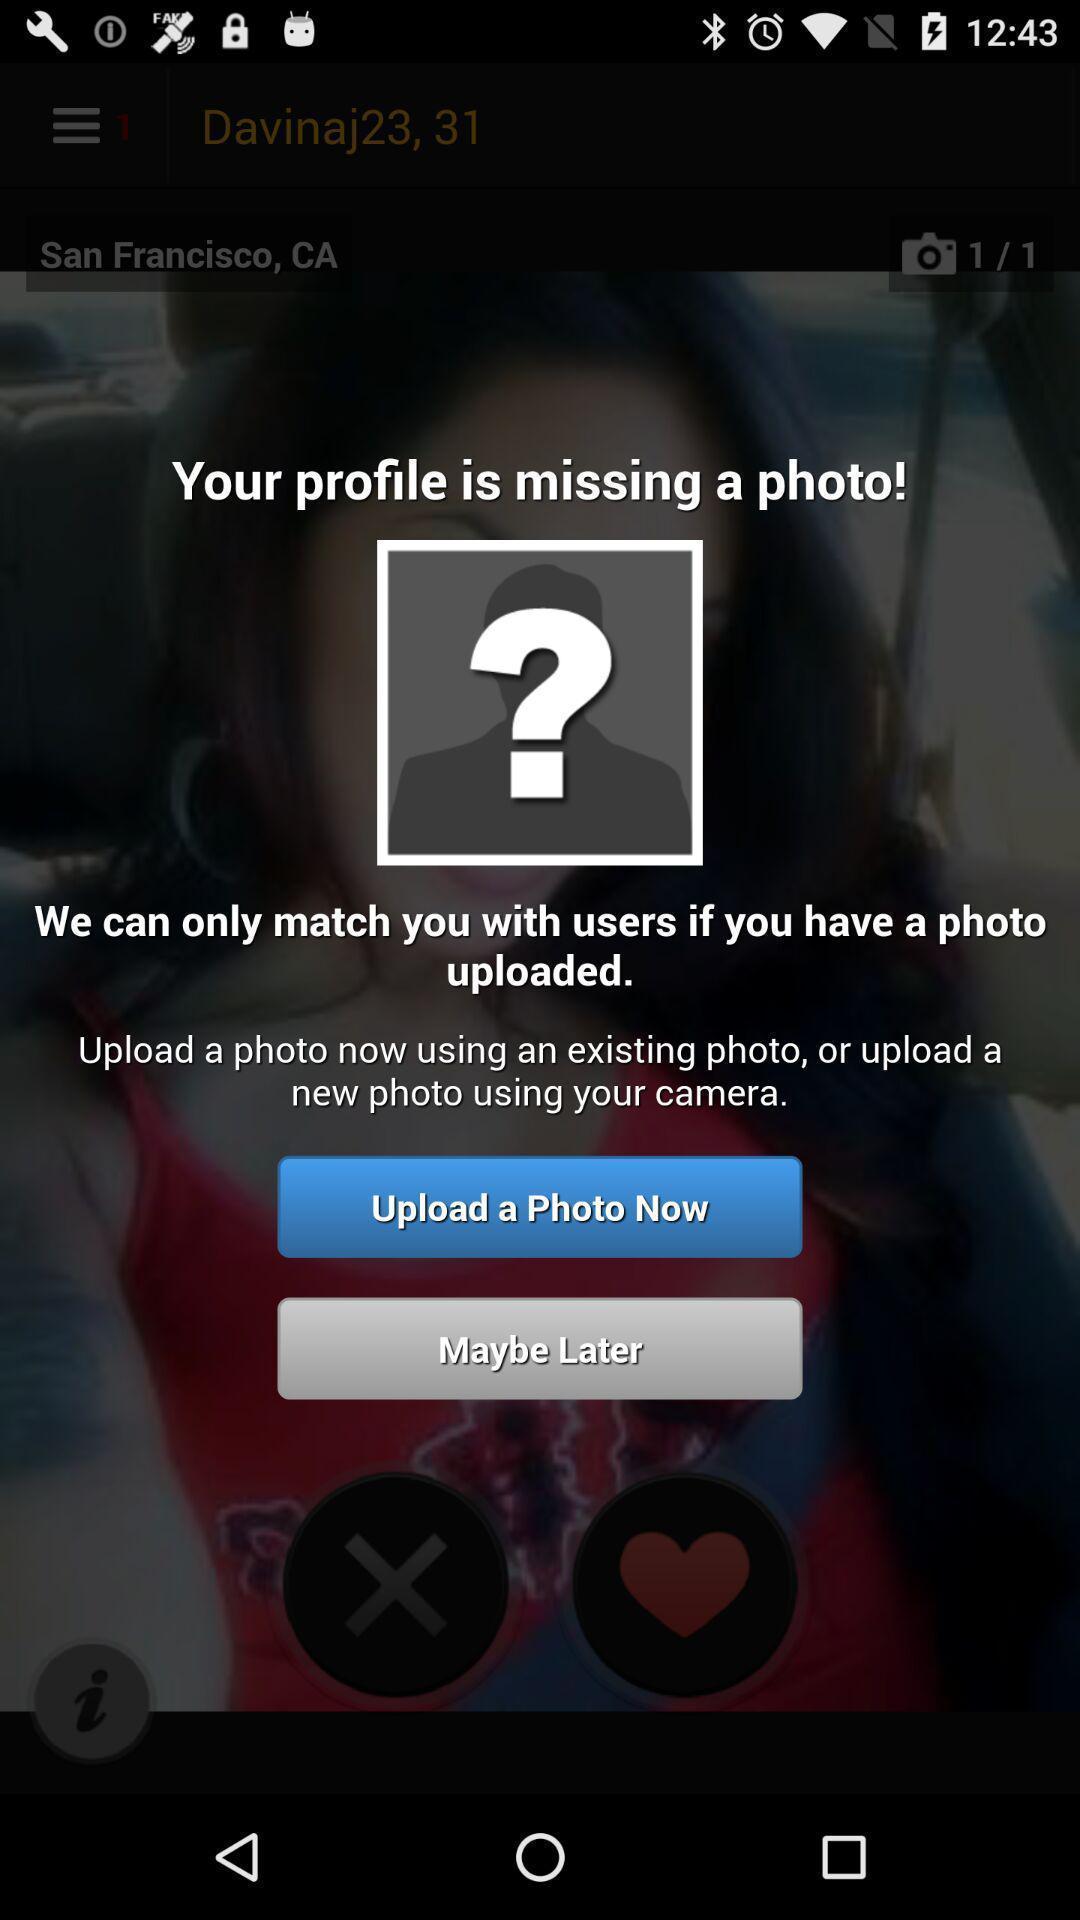Explain the elements present in this screenshot. Pop-up shows profile details. 